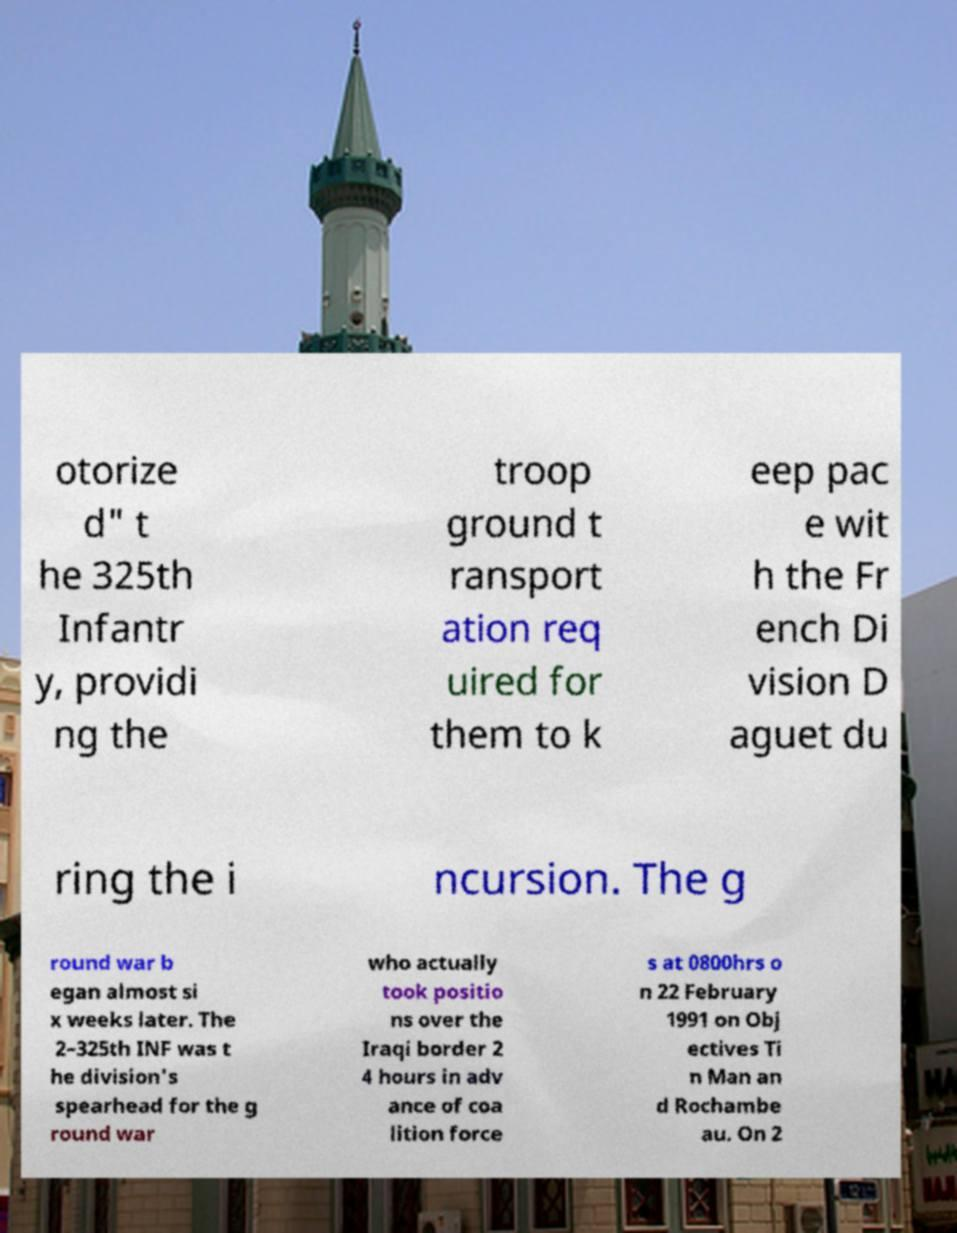Can you read and provide the text displayed in the image?This photo seems to have some interesting text. Can you extract and type it out for me? otorize d" t he 325th Infantr y, providi ng the troop ground t ransport ation req uired for them to k eep pac e wit h the Fr ench Di vision D aguet du ring the i ncursion. The g round war b egan almost si x weeks later. The 2–325th INF was t he division's spearhead for the g round war who actually took positio ns over the Iraqi border 2 4 hours in adv ance of coa lition force s at 0800hrs o n 22 February 1991 on Obj ectives Ti n Man an d Rochambe au. On 2 